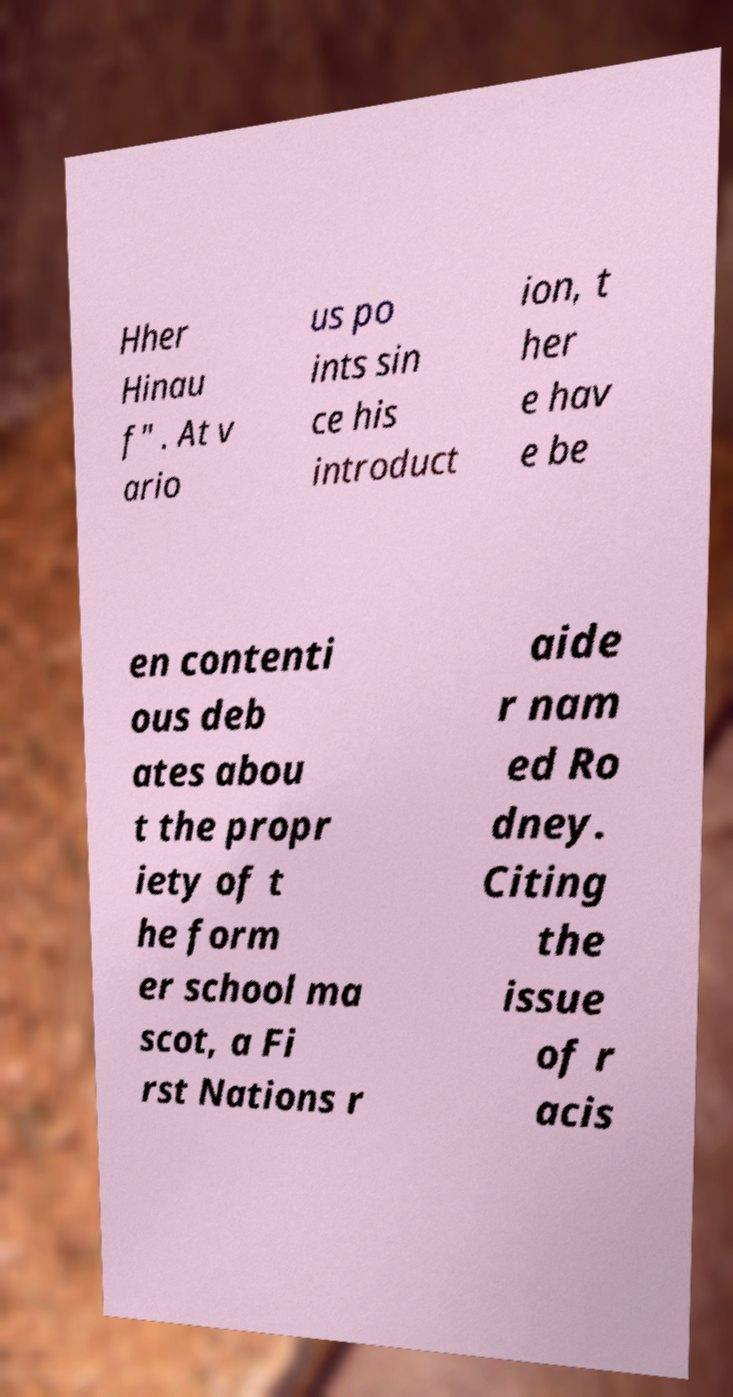Could you extract and type out the text from this image? Hher Hinau f" . At v ario us po ints sin ce his introduct ion, t her e hav e be en contenti ous deb ates abou t the propr iety of t he form er school ma scot, a Fi rst Nations r aide r nam ed Ro dney. Citing the issue of r acis 